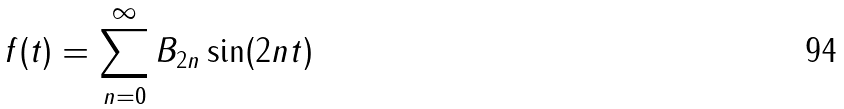<formula> <loc_0><loc_0><loc_500><loc_500>f ( t ) = \sum _ { n = 0 } ^ { \infty } B _ { 2 n } \sin ( 2 n t )</formula> 